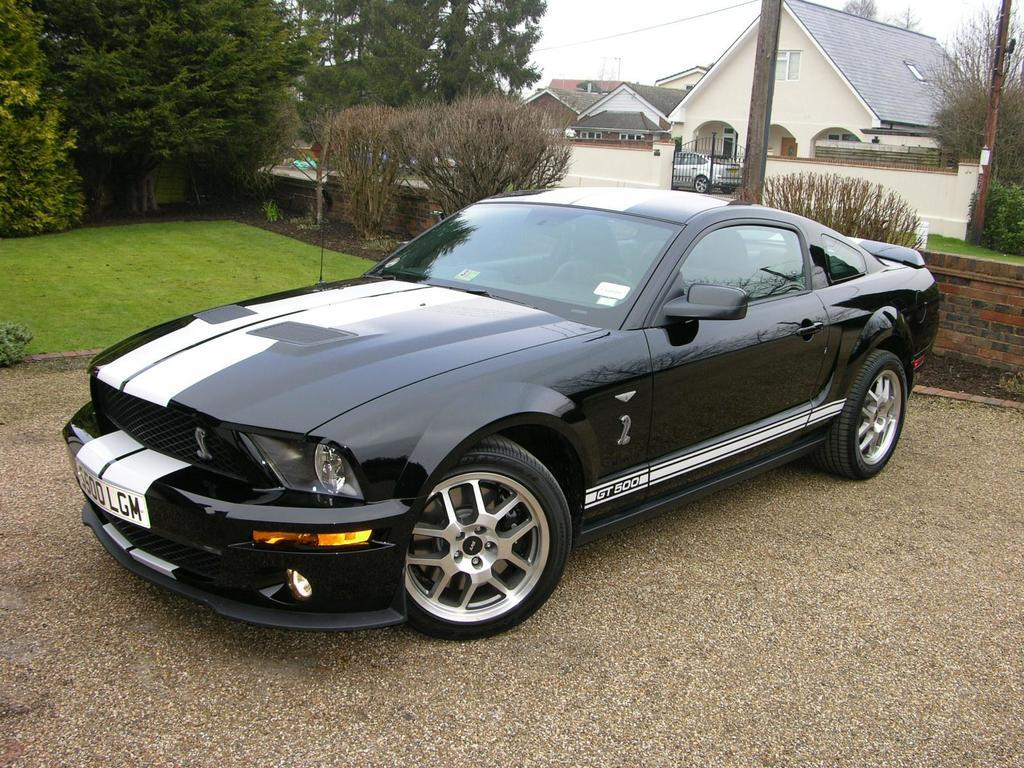What is the main subject in the foreground of the image? There is a car in the foreground of the image. What is the position of the car in relation to the ground? The car is on the ground. What type of natural environment can be seen in the background of the image? There are trees, grassland, and the sky visible in the background of the image. What man-made structures are present in the background of the image? There is a wall, a pole, and buildings visible in the background of the image. What type of lift is being used to transport the car in the image? There is no lift present in the image, and the car is already on the ground. 